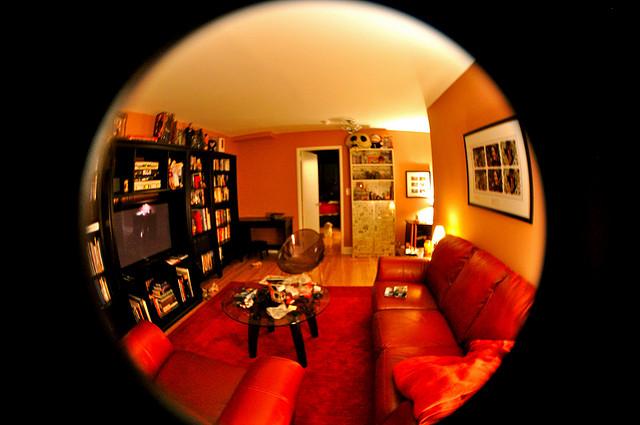What is strange about the view of this photo?
Write a very short answer. Peephole view. What is the top of the coffee table made of?
Quick response, please. Glass. Is the television on?
Keep it brief. No. 